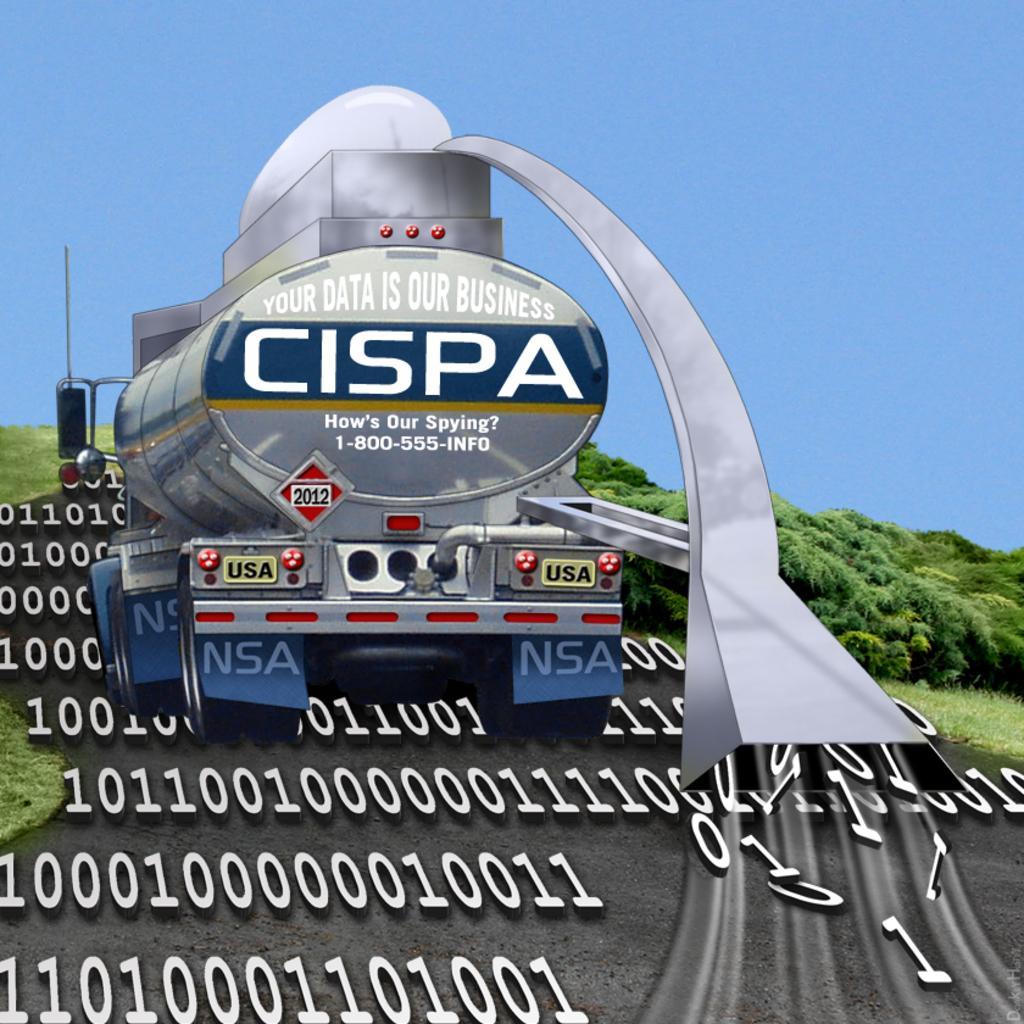Can you describe this image briefly? In this image I can see a vehicle on the road, numbers, grass, trees and the sky. This image looks like an edited photo. 